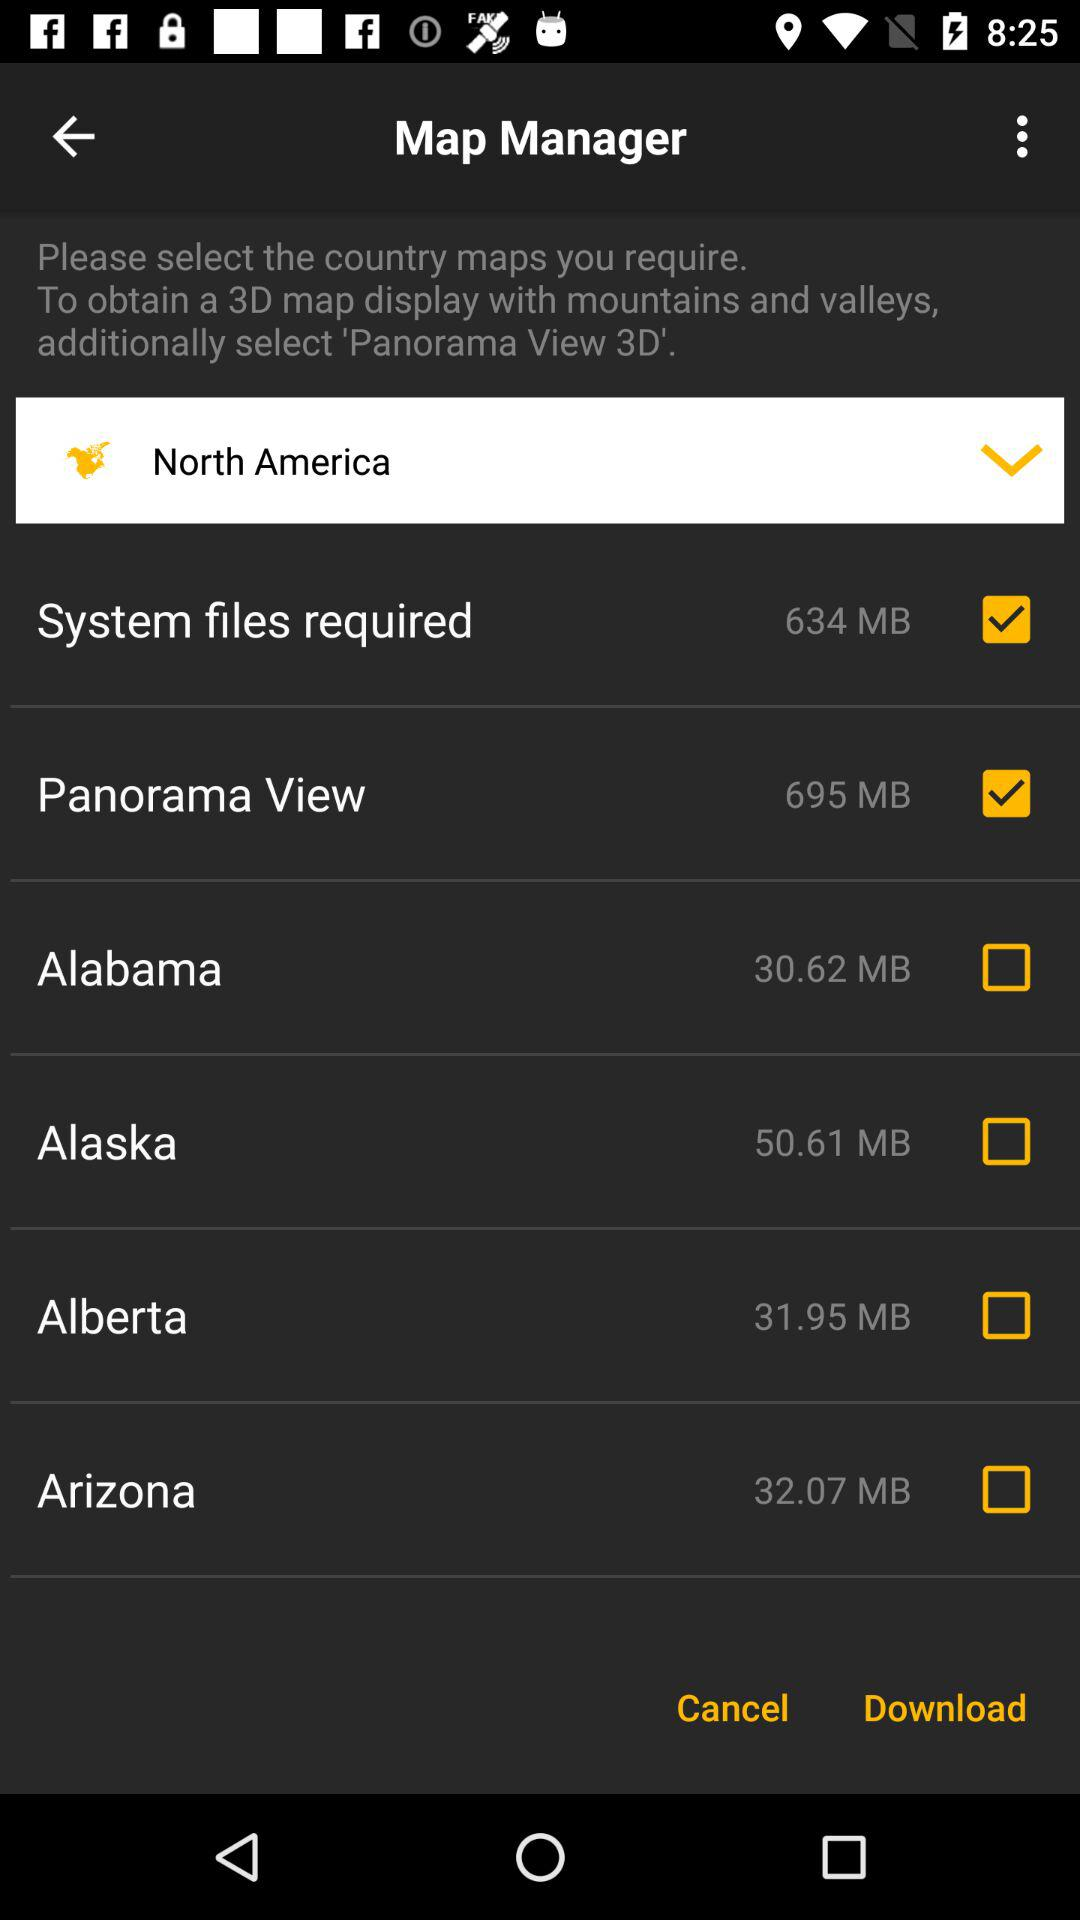Which location is selected? The selected location is North America. 